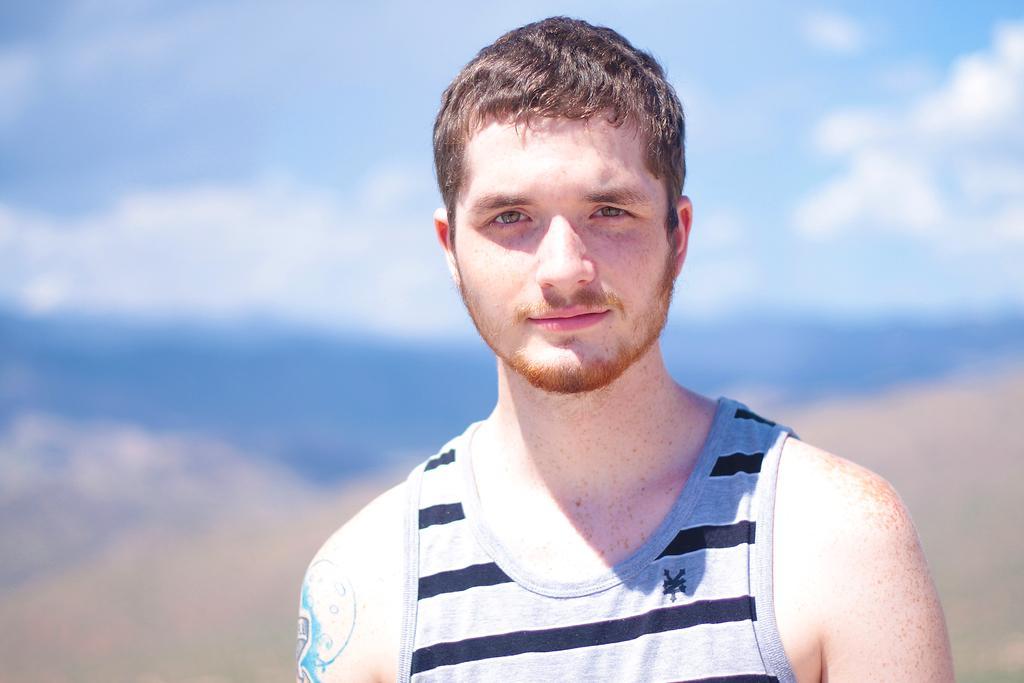Please provide a concise description of this image. This picture shows a man standing and we see blue cloudy sky. 